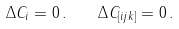<formula> <loc_0><loc_0><loc_500><loc_500>\Delta C _ { i } = 0 \, . \quad \Delta C _ { [ i j k ] } = 0 \, .</formula> 